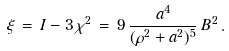<formula> <loc_0><loc_0><loc_500><loc_500>\xi \, = \, I - 3 \, \chi ^ { 2 } \, = \, 9 \, \frac { a ^ { 4 } } { ( \rho ^ { 2 } + a ^ { 2 } ) ^ { 5 } } \, B ^ { 2 } \, .</formula> 